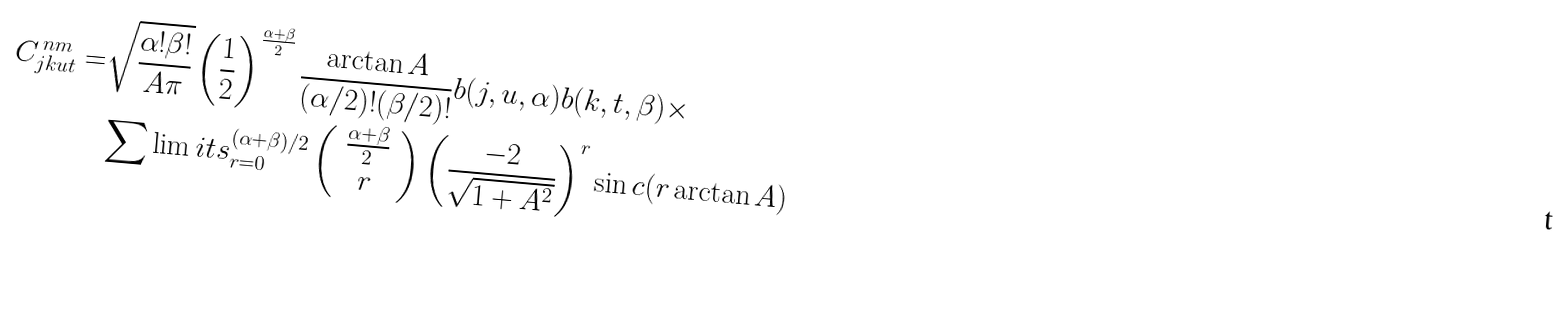<formula> <loc_0><loc_0><loc_500><loc_500>C ^ { \, n m } _ { j k u t } = & \sqrt { \frac { \alpha ! \beta ! } { A \pi } } \left ( \frac { 1 } { 2 } \right ) ^ { \frac { \alpha + \beta } { 2 } } \frac { \arctan A } { ( \alpha / 2 ) ! ( \beta / 2 ) ! } b ( j , u , \alpha ) b ( k , t , \beta ) \times \\ & \sum \lim i t s _ { r = 0 } ^ { ( \alpha + \beta ) / 2 } \left ( \begin{array} { c } \frac { \alpha + \beta } { 2 } \\ r \end{array} \right ) \left ( \frac { - 2 } { \sqrt { 1 + A ^ { 2 } } } \right ) ^ { r } \sin c ( r \arctan A )</formula> 